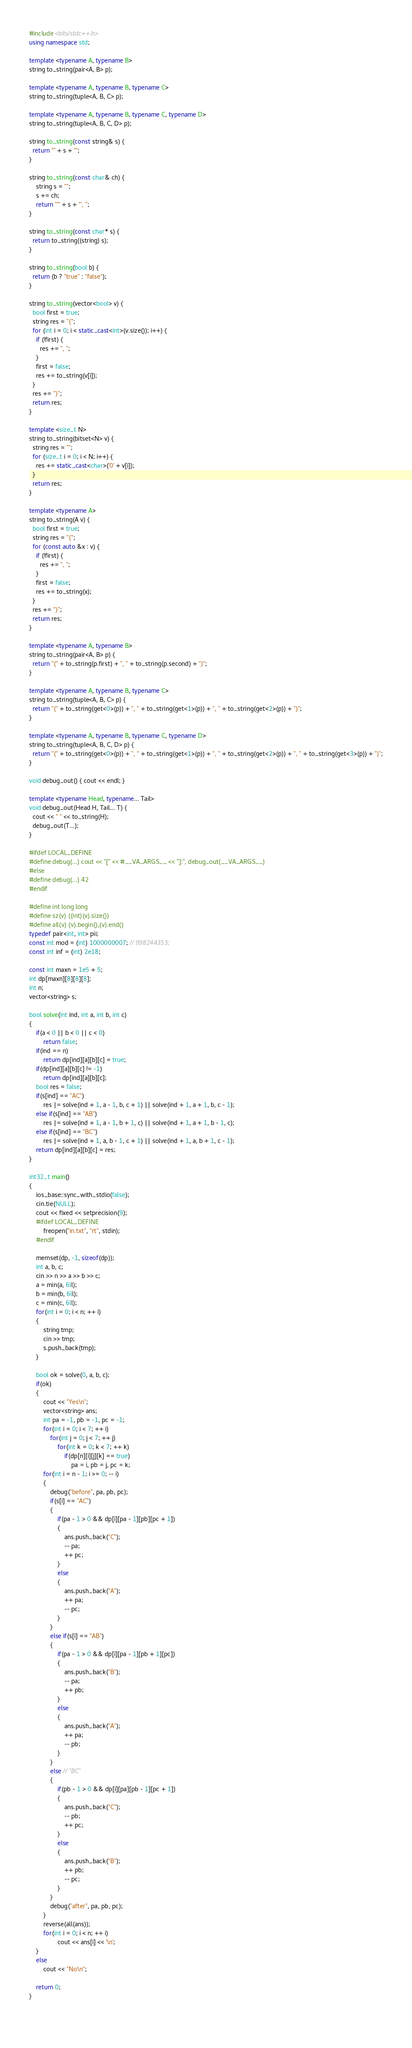Convert code to text. <code><loc_0><loc_0><loc_500><loc_500><_C++_>#include <bits/stdc++.h>
using namespace std;
 
template <typename A, typename B>
string to_string(pair<A, B> p);
 
template <typename A, typename B, typename C>
string to_string(tuple<A, B, C> p);
 
template <typename A, typename B, typename C, typename D>
string to_string(tuple<A, B, C, D> p);
 
string to_string(const string& s) {
  return '"' + s + '"';
}
 
string to_string(const char& ch) {
	string s = "";
	s += ch;
	return "'" + s + "', ";
}
 
string to_string(const char* s) {
  return to_string((string) s);
}
 
string to_string(bool b) {
  return (b ? "true" : "false");
}
 
string to_string(vector<bool> v) {
  bool first = true;
  string res = "{";
  for (int i = 0; i < static_cast<int>(v.size()); i++) {
    if (!first) {
      res += ", ";
    }
    first = false;
    res += to_string(v[i]);
  }
  res += "}";
  return res;
}
 
template <size_t N>
string to_string(bitset<N> v) {
  string res = "";
  for (size_t i = 0; i < N; i++) {
    res += static_cast<char>('0' + v[i]);
  }
  return res;
}
 
template <typename A>
string to_string(A v) {
  bool first = true;
  string res = "{";
  for (const auto &x : v) {
    if (!first) {
      res += ", ";
    }
    first = false;
    res += to_string(x);
  }
  res += "}";
  return res;
}
 
template <typename A, typename B>
string to_string(pair<A, B> p) {
  return "(" + to_string(p.first) + ", " + to_string(p.second) + ")";
}
 
template <typename A, typename B, typename C>
string to_string(tuple<A, B, C> p) {
  return "(" + to_string(get<0>(p)) + ", " + to_string(get<1>(p)) + ", " + to_string(get<2>(p)) + ")";
}
 
template <typename A, typename B, typename C, typename D>
string to_string(tuple<A, B, C, D> p) {
  return "(" + to_string(get<0>(p)) + ", " + to_string(get<1>(p)) + ", " + to_string(get<2>(p)) + ", " + to_string(get<3>(p)) + ")";
}
 
void debug_out() { cout << endl; }
 
template <typename Head, typename... Tail>
void debug_out(Head H, Tail... T) {
  cout << " " << to_string(H);
  debug_out(T...);
}
 
#ifdef LOCAL_DEFINE
#define debug(...) cout << "[" << #__VA_ARGS__ << "]:", debug_out(__VA_ARGS__)
#else
#define debug(...) 42
#endif
   
#define int long long
#define sz(v) ((int)(v).size())
#define all(v) (v).begin(),(v).end()
typedef pair<int, int> pii;
const int mod = (int) 1000000007; // 998244353;
const int inf = (int) 2e18;

const int maxn = 1e5 + 5;
int dp[maxn][8][8][8];
int n;
vector<string> s;

bool solve(int ind, int a, int b, int c)
{
	if(a < 0 || b < 0 || c < 0)
		return false;
	if(ind == n)
		return dp[ind][a][b][c] = true;
	if(dp[ind][a][b][c] != -1)
		return dp[ind][a][b][c];
	bool res = false;
	if(s[ind] == "AC")
		res |= solve(ind + 1, a - 1, b, c + 1) || solve(ind + 1, a + 1, b, c - 1);
	else if(s[ind] == "AB")
		res |= solve(ind + 1, a - 1, b + 1, c) || solve(ind + 1, a + 1, b - 1, c);
	else if(s[ind] == "BC")
		res |= solve(ind + 1, a, b - 1, c + 1) || solve(ind + 1, a, b + 1, c - 1);
	return dp[ind][a][b][c] = res;
}

int32_t main()
{
	ios_base::sync_with_stdio(false);
	cin.tie(NULL);
	cout << fixed << setprecision(9);
	#ifdef LOCAL_DEFINE
		freopen("in.txt", "rt", stdin);
	#endif
	
	memset(dp, -1, sizeof(dp));
	int a, b, c;
	cin >> n >> a >> b >> c;
	a = min(a, 6ll);
	b = min(b, 6ll);
	c = min(c, 6ll);
	for(int i = 0; i < n; ++ i)
	{
		string tmp;
		cin >> tmp;
		s.push_back(tmp);
	}
	
	bool ok = solve(0, a, b, c);
	if(ok)
	{
		cout << "Yes\n";
		vector<string> ans;
		int pa = -1, pb = -1, pc = -1;
		for(int i = 0; i < 7; ++ i)
			for(int j = 0; j < 7; ++ j)
				for(int k = 0; k < 7; ++ k)
					if(dp[n][i][j][k] == true)
						pa = i, pb = j, pc = k;
		for(int i = n - 1; i >= 0; -- i)
		{
			debug("before", pa, pb, pc);
			if(s[i] == "AC")
			{
				if(pa - 1 > 0 && dp[i][pa - 1][pb][pc + 1])
				{
					ans.push_back("C");
					-- pa;
					++ pc;
				}
				else
				{
					ans.push_back("A");
					++ pa;
					-- pc;
				}
			}
			else if(s[i] == "AB")
			{
				if(pa - 1 > 0 && dp[i][pa - 1][pb + 1][pc])
				{
					ans.push_back("B");
					-- pa;
					++ pb;
				}
				else
				{
					ans.push_back("A");
					++ pa;
					-- pb;
				}
			}
			else // "BC"
			{
				if(pb - 1 > 0 && dp[i][pa][pb - 1][pc + 1])
				{
					ans.push_back("C");
					-- pb;
					++ pc;
				}
				else
				{
					ans.push_back("B");
					++ pb;
					-- pc;
				}
			}
			debug("after", pa, pb, pc);
		}
		reverse(all(ans));
		for(int i = 0; i < n; ++ i)
				cout << ans[i] << '\n';
	}
	else
		cout << "No\n";
	
	return 0;
}
 
 </code> 